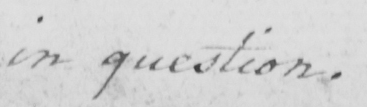Please transcribe the handwritten text in this image. in question . 